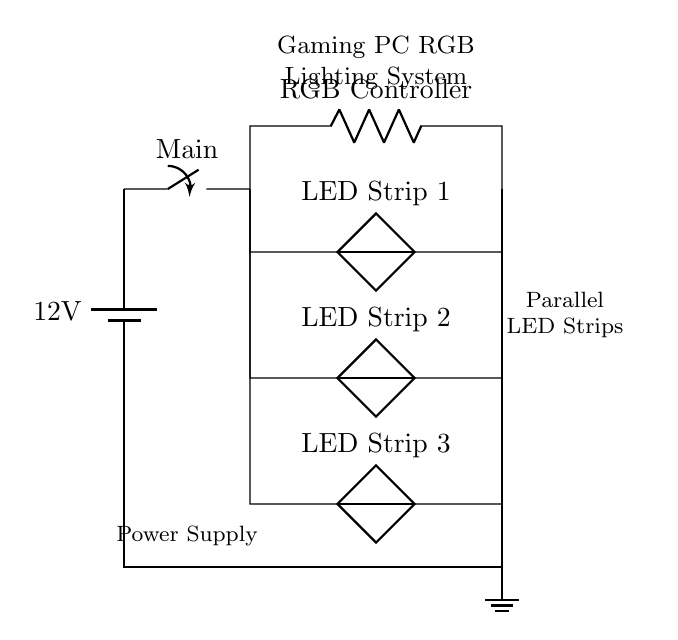What is the voltage of the power supply? The circuit diagram shows a battery marked with a voltage of 12 volts, which indicates the voltage provided by the power supply.
Answer: 12 volts How many LED strips are connected in parallel? The diagram indicates three LED strips connected in parallel, as shown by three separate branches leading from the common connection point.
Answer: Three What component is labeled as the RGB Controller? The RGB Controller is located in the middle branch of the diagram, above the LED strips, where it is labeled and connected to the main switch.
Answer: RGB Controller What happens if one LED strip fails? In a parallel circuit, each LED strip operates independently. If one fails, the others will continue to function normally since they have their own branches to the power supply.
Answer: Others continue to function How is the ground connected in this circuit? The ground is connected at the bottom of the circuit diagram, marked with a ground symbol, joining the negative side of the power supply to the common ground for all components.
Answer: Ground symbol What type of circuit is represented in this diagram? The circuit diagram exemplifies a parallel circuit, as illustrated by the multiple branches emanating from a single power source, allowing components to operate independently.
Answer: Parallel circuit 